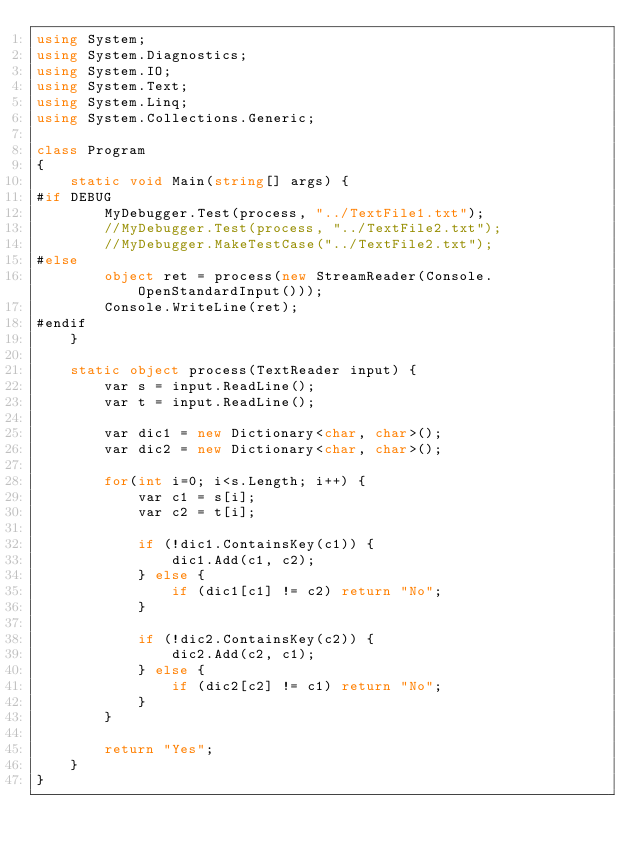<code> <loc_0><loc_0><loc_500><loc_500><_C#_>using System;
using System.Diagnostics;
using System.IO;
using System.Text;
using System.Linq;
using System.Collections.Generic;

class Program
{
    static void Main(string[] args) {
#if DEBUG
        MyDebugger.Test(process, "../TextFile1.txt");
        //MyDebugger.Test(process, "../TextFile2.txt");
        //MyDebugger.MakeTestCase("../TextFile2.txt");
#else
        object ret = process(new StreamReader(Console.OpenStandardInput()));
        Console.WriteLine(ret);
#endif
    }

    static object process(TextReader input) {
        var s = input.ReadLine();
        var t = input.ReadLine();

        var dic1 = new Dictionary<char, char>();
        var dic2 = new Dictionary<char, char>();

        for(int i=0; i<s.Length; i++) {
            var c1 = s[i];
            var c2 = t[i];

            if (!dic1.ContainsKey(c1)) {
                dic1.Add(c1, c2);
            } else {
                if (dic1[c1] != c2) return "No";
            }

            if (!dic2.ContainsKey(c2)) {
                dic2.Add(c2, c1);
            } else {
                if (dic2[c2] != c1) return "No";
            }
        }

        return "Yes";
    }
}</code> 